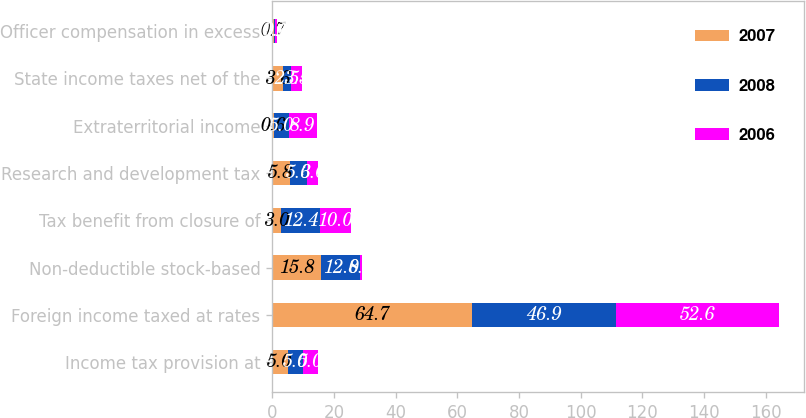<chart> <loc_0><loc_0><loc_500><loc_500><stacked_bar_chart><ecel><fcel>Income tax provision at<fcel>Foreign income taxed at rates<fcel>Non-deductible stock-based<fcel>Tax benefit from closure of<fcel>Research and development tax<fcel>Extraterritorial income<fcel>State income taxes net of the<fcel>Officer compensation in excess<nl><fcel>2007<fcel>5<fcel>64.7<fcel>15.8<fcel>3<fcel>5.8<fcel>0.6<fcel>3.6<fcel>0.7<nl><fcel>2008<fcel>5<fcel>46.9<fcel>12.8<fcel>12.4<fcel>5.6<fcel>5<fcel>2.5<fcel>0.2<nl><fcel>2006<fcel>5<fcel>52.6<fcel>0.5<fcel>10<fcel>3.6<fcel>8.9<fcel>3.5<fcel>0.6<nl></chart> 